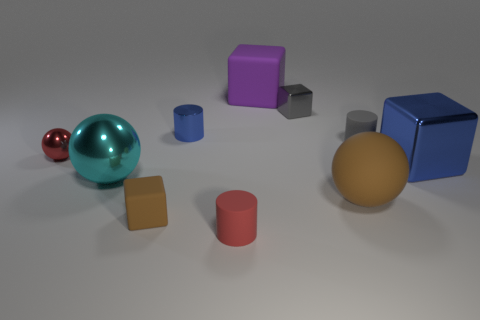Subtract all brown matte blocks. How many blocks are left? 3 Subtract all blue cylinders. How many cylinders are left? 2 Subtract 1 blocks. How many blocks are left? 3 Subtract all cubes. How many objects are left? 6 Subtract all tiny brown objects. Subtract all rubber blocks. How many objects are left? 7 Add 1 large blue things. How many large blue things are left? 2 Add 7 brown cubes. How many brown cubes exist? 8 Subtract 0 yellow blocks. How many objects are left? 10 Subtract all yellow balls. Subtract all cyan blocks. How many balls are left? 3 Subtract all green cubes. How many cyan spheres are left? 1 